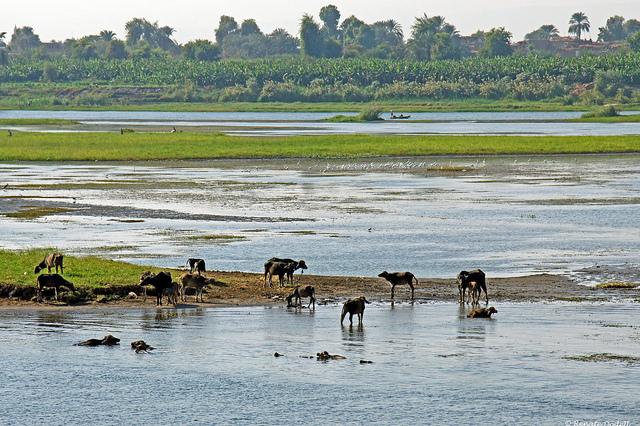What number of animals are on the beach?
Concise answer only. 10. Is this a protected habitat?
Concise answer only. Yes. What are the animals doing?
Be succinct. Drinking. 